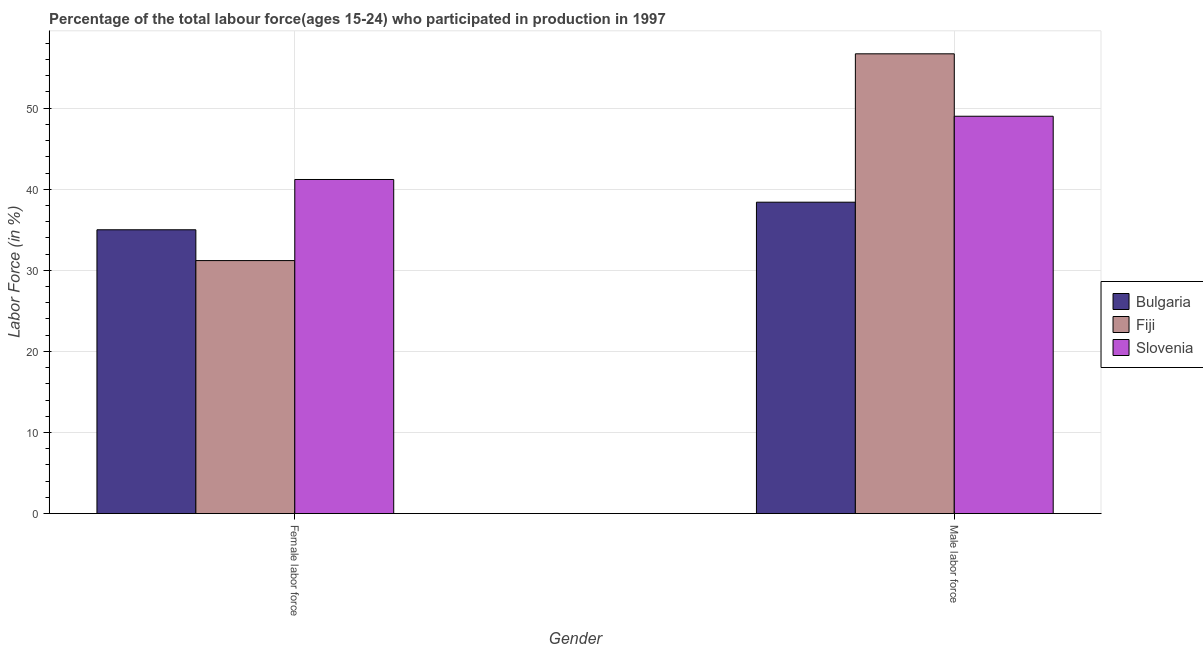Are the number of bars on each tick of the X-axis equal?
Offer a terse response. Yes. How many bars are there on the 1st tick from the right?
Provide a short and direct response. 3. What is the label of the 1st group of bars from the left?
Provide a short and direct response. Female labor force. What is the percentage of female labor force in Slovenia?
Provide a succinct answer. 41.2. Across all countries, what is the maximum percentage of male labour force?
Provide a succinct answer. 56.7. Across all countries, what is the minimum percentage of male labour force?
Provide a succinct answer. 38.4. In which country was the percentage of male labour force maximum?
Offer a terse response. Fiji. In which country was the percentage of female labor force minimum?
Your answer should be compact. Fiji. What is the total percentage of female labor force in the graph?
Offer a very short reply. 107.4. What is the difference between the percentage of male labour force in Slovenia and that in Bulgaria?
Your answer should be compact. 10.6. What is the average percentage of male labour force per country?
Provide a short and direct response. 48.03. What is the difference between the percentage of female labor force and percentage of male labour force in Fiji?
Your answer should be very brief. -25.5. In how many countries, is the percentage of male labour force greater than 16 %?
Your answer should be very brief. 3. What is the ratio of the percentage of male labour force in Fiji to that in Bulgaria?
Make the answer very short. 1.48. What does the 1st bar from the left in Female labor force represents?
Offer a very short reply. Bulgaria. What does the 1st bar from the right in Male labor force represents?
Make the answer very short. Slovenia. Are all the bars in the graph horizontal?
Provide a short and direct response. No. What is the difference between two consecutive major ticks on the Y-axis?
Offer a terse response. 10. Where does the legend appear in the graph?
Ensure brevity in your answer.  Center right. What is the title of the graph?
Offer a terse response. Percentage of the total labour force(ages 15-24) who participated in production in 1997. Does "Guinea" appear as one of the legend labels in the graph?
Ensure brevity in your answer.  No. What is the label or title of the X-axis?
Offer a terse response. Gender. What is the Labor Force (in %) of Bulgaria in Female labor force?
Your answer should be very brief. 35. What is the Labor Force (in %) of Fiji in Female labor force?
Your answer should be compact. 31.2. What is the Labor Force (in %) of Slovenia in Female labor force?
Your response must be concise. 41.2. What is the Labor Force (in %) of Bulgaria in Male labor force?
Your response must be concise. 38.4. What is the Labor Force (in %) in Fiji in Male labor force?
Your response must be concise. 56.7. Across all Gender, what is the maximum Labor Force (in %) of Bulgaria?
Offer a terse response. 38.4. Across all Gender, what is the maximum Labor Force (in %) of Fiji?
Provide a short and direct response. 56.7. Across all Gender, what is the maximum Labor Force (in %) in Slovenia?
Your response must be concise. 49. Across all Gender, what is the minimum Labor Force (in %) of Fiji?
Your response must be concise. 31.2. Across all Gender, what is the minimum Labor Force (in %) in Slovenia?
Make the answer very short. 41.2. What is the total Labor Force (in %) in Bulgaria in the graph?
Provide a succinct answer. 73.4. What is the total Labor Force (in %) in Fiji in the graph?
Your response must be concise. 87.9. What is the total Labor Force (in %) of Slovenia in the graph?
Your response must be concise. 90.2. What is the difference between the Labor Force (in %) of Bulgaria in Female labor force and that in Male labor force?
Ensure brevity in your answer.  -3.4. What is the difference between the Labor Force (in %) of Fiji in Female labor force and that in Male labor force?
Provide a short and direct response. -25.5. What is the difference between the Labor Force (in %) of Bulgaria in Female labor force and the Labor Force (in %) of Fiji in Male labor force?
Your answer should be very brief. -21.7. What is the difference between the Labor Force (in %) of Fiji in Female labor force and the Labor Force (in %) of Slovenia in Male labor force?
Give a very brief answer. -17.8. What is the average Labor Force (in %) of Bulgaria per Gender?
Ensure brevity in your answer.  36.7. What is the average Labor Force (in %) of Fiji per Gender?
Make the answer very short. 43.95. What is the average Labor Force (in %) in Slovenia per Gender?
Offer a terse response. 45.1. What is the difference between the Labor Force (in %) in Fiji and Labor Force (in %) in Slovenia in Female labor force?
Make the answer very short. -10. What is the difference between the Labor Force (in %) in Bulgaria and Labor Force (in %) in Fiji in Male labor force?
Your response must be concise. -18.3. What is the difference between the Labor Force (in %) of Fiji and Labor Force (in %) of Slovenia in Male labor force?
Offer a very short reply. 7.7. What is the ratio of the Labor Force (in %) in Bulgaria in Female labor force to that in Male labor force?
Give a very brief answer. 0.91. What is the ratio of the Labor Force (in %) in Fiji in Female labor force to that in Male labor force?
Provide a short and direct response. 0.55. What is the ratio of the Labor Force (in %) in Slovenia in Female labor force to that in Male labor force?
Provide a short and direct response. 0.84. What is the difference between the highest and the second highest Labor Force (in %) in Bulgaria?
Provide a succinct answer. 3.4. What is the difference between the highest and the second highest Labor Force (in %) of Fiji?
Provide a succinct answer. 25.5. What is the difference between the highest and the lowest Labor Force (in %) of Bulgaria?
Make the answer very short. 3.4. What is the difference between the highest and the lowest Labor Force (in %) in Fiji?
Offer a very short reply. 25.5. 